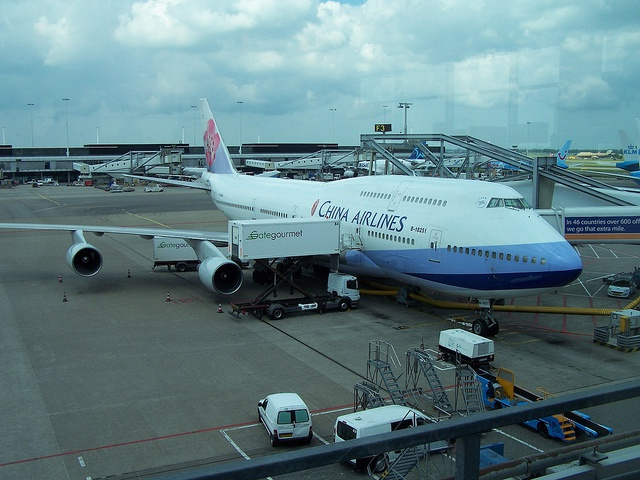Describe the objects in this image and their specific colors. I can see airplane in lightblue, darkgray, and black tones, car in lightblue, black, gray, and blue tones, truck in lightblue, black, and teal tones, car in lightblue, black, and teal tones, and airplane in lightblue and teal tones in this image. 